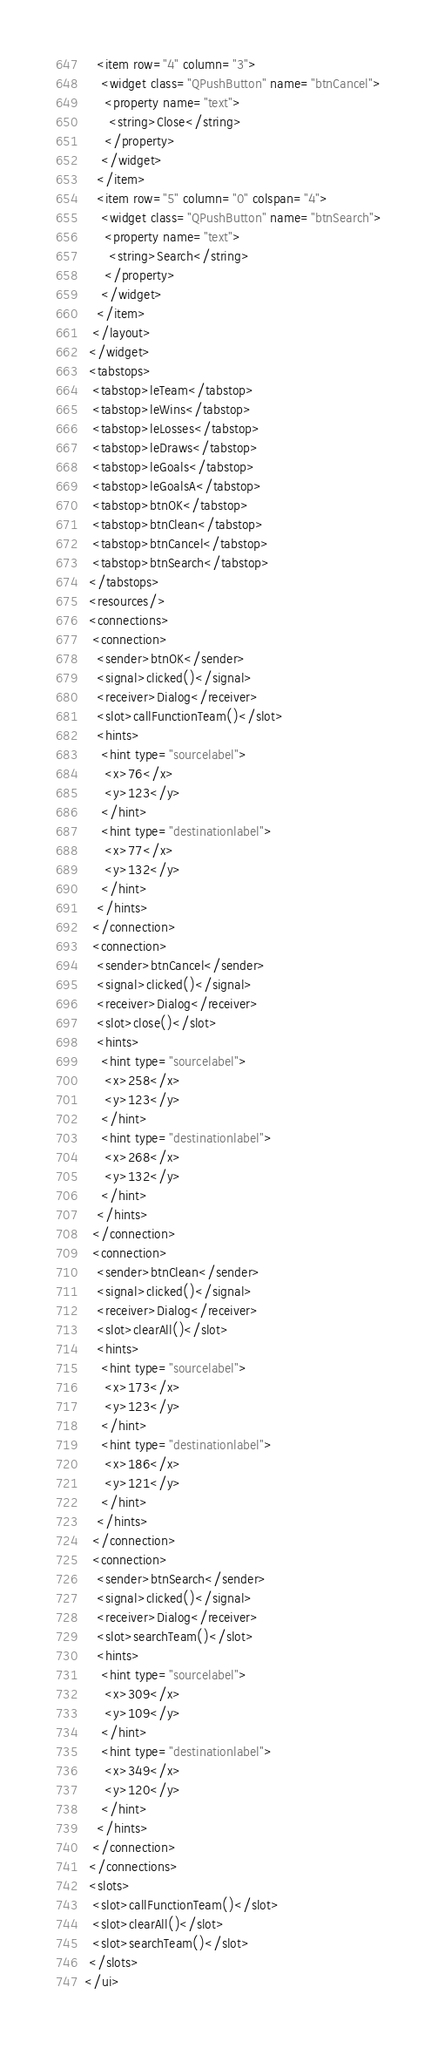<code> <loc_0><loc_0><loc_500><loc_500><_XML_>   <item row="4" column="3">
    <widget class="QPushButton" name="btnCancel">
     <property name="text">
      <string>Close</string>
     </property>
    </widget>
   </item>
   <item row="5" column="0" colspan="4">
    <widget class="QPushButton" name="btnSearch">
     <property name="text">
      <string>Search</string>
     </property>
    </widget>
   </item>
  </layout>
 </widget>
 <tabstops>
  <tabstop>leTeam</tabstop>
  <tabstop>leWins</tabstop>
  <tabstop>leLosses</tabstop>
  <tabstop>leDraws</tabstop>
  <tabstop>leGoals</tabstop>
  <tabstop>leGoalsA</tabstop>
  <tabstop>btnOK</tabstop>
  <tabstop>btnClean</tabstop>
  <tabstop>btnCancel</tabstop>
  <tabstop>btnSearch</tabstop>
 </tabstops>
 <resources/>
 <connections>
  <connection>
   <sender>btnOK</sender>
   <signal>clicked()</signal>
   <receiver>Dialog</receiver>
   <slot>callFunctionTeam()</slot>
   <hints>
    <hint type="sourcelabel">
     <x>76</x>
     <y>123</y>
    </hint>
    <hint type="destinationlabel">
     <x>77</x>
     <y>132</y>
    </hint>
   </hints>
  </connection>
  <connection>
   <sender>btnCancel</sender>
   <signal>clicked()</signal>
   <receiver>Dialog</receiver>
   <slot>close()</slot>
   <hints>
    <hint type="sourcelabel">
     <x>258</x>
     <y>123</y>
    </hint>
    <hint type="destinationlabel">
     <x>268</x>
     <y>132</y>
    </hint>
   </hints>
  </connection>
  <connection>
   <sender>btnClean</sender>
   <signal>clicked()</signal>
   <receiver>Dialog</receiver>
   <slot>clearAll()</slot>
   <hints>
    <hint type="sourcelabel">
     <x>173</x>
     <y>123</y>
    </hint>
    <hint type="destinationlabel">
     <x>186</x>
     <y>121</y>
    </hint>
   </hints>
  </connection>
  <connection>
   <sender>btnSearch</sender>
   <signal>clicked()</signal>
   <receiver>Dialog</receiver>
   <slot>searchTeam()</slot>
   <hints>
    <hint type="sourcelabel">
     <x>309</x>
     <y>109</y>
    </hint>
    <hint type="destinationlabel">
     <x>349</x>
     <y>120</y>
    </hint>
   </hints>
  </connection>
 </connections>
 <slots>
  <slot>callFunctionTeam()</slot>
  <slot>clearAll()</slot>
  <slot>searchTeam()</slot>
 </slots>
</ui>
</code> 